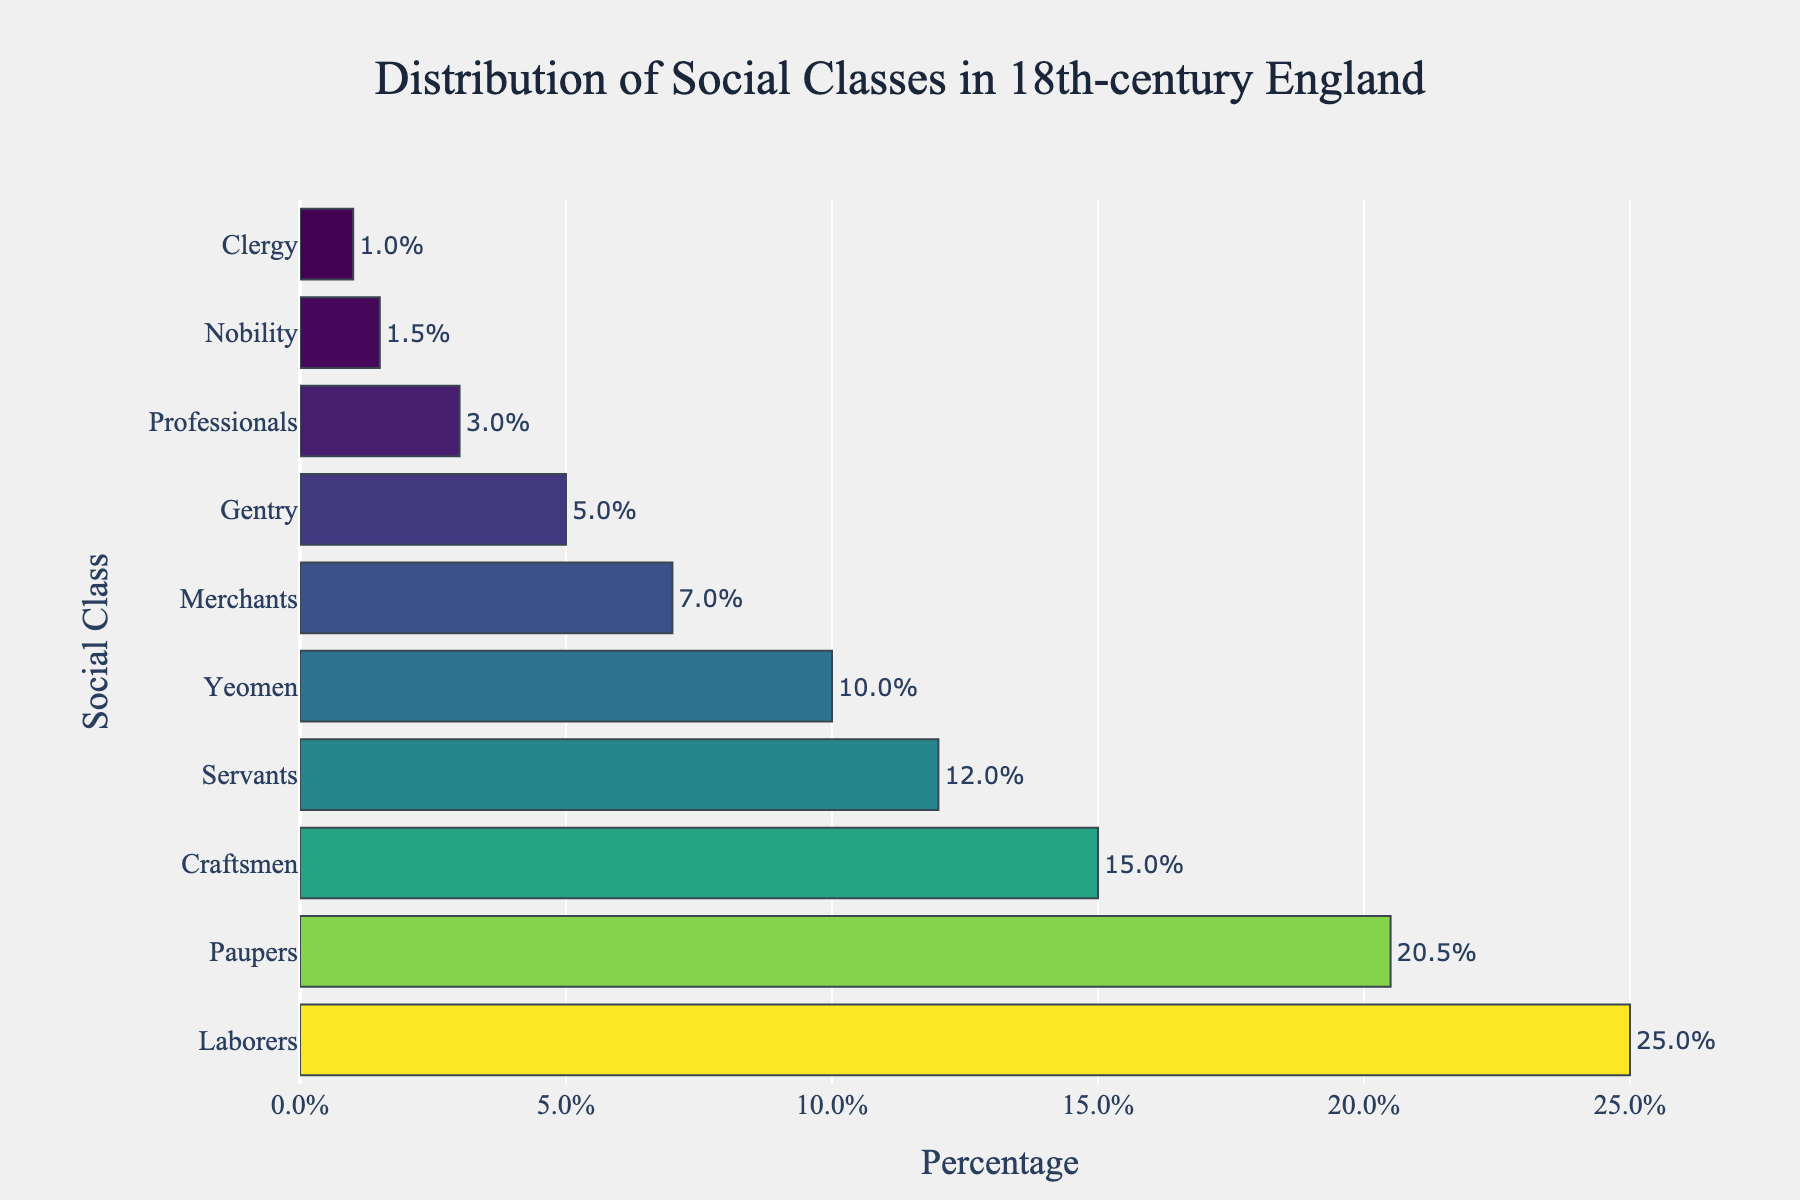What is the percentage of the Paupers class? The bar representing the Paupers class is situated toward the top in the figure. The percentage label attached to this bar shows 20.5%.
Answer: 20.5% Which social class has the smallest representation? The smallest bar in the graph corresponds to the Clergy class. The percentage label reads 1%.
Answer: Clergy How does the percentage of Merchants compare to the percentage of Professionals? To compare the percentages, observe that the Merchants bar is longer than the Professionals bar. Merchants are at 7%, while Professionals are at 3%.
Answer: Merchants have a higher percentage What is the combined percentage of Nobility, Gentry, and Clergy? Add the percentages for Nobility (1.5%), Gentry (5%), and Clergy (1%). The sum is 1.5% + 5% + 1% = 7.5%.
Answer: 7.5% Which social class is represented by the longest bar? Visually, the longest bar in the figure belongs to the Laborers class, as indicated by the percentage label of 25%.
Answer: Laborers By how much does the percentage of Yeomen exceed that of Clergy? Subtract the Clergy percentage (1%) from the Yeomen percentage (10%). This results in 10% - 1% = 9%.
Answer: 9% What is the average percentage of the Servants and Paupers classes? Sum the percentages of Servants (12%) and Paupers (20.5%), which gives 32.5%. Divide this by 2 to find the average: 32.5% / 2 = 16.25%.
Answer: 16.25% Which two social classes have the most similar percentages? The percentages for Professionals (3%) and Clergy (1%) are quite different. However, the percentages for Servants (12%) and Professionals (7%) are not as close as those for Gentry and Nobility, which are 5% and 1.5%, respectively. The closest two are Gentry and Nobility, with a difference of 3.5%.
Answer: Gentry and Nobility 